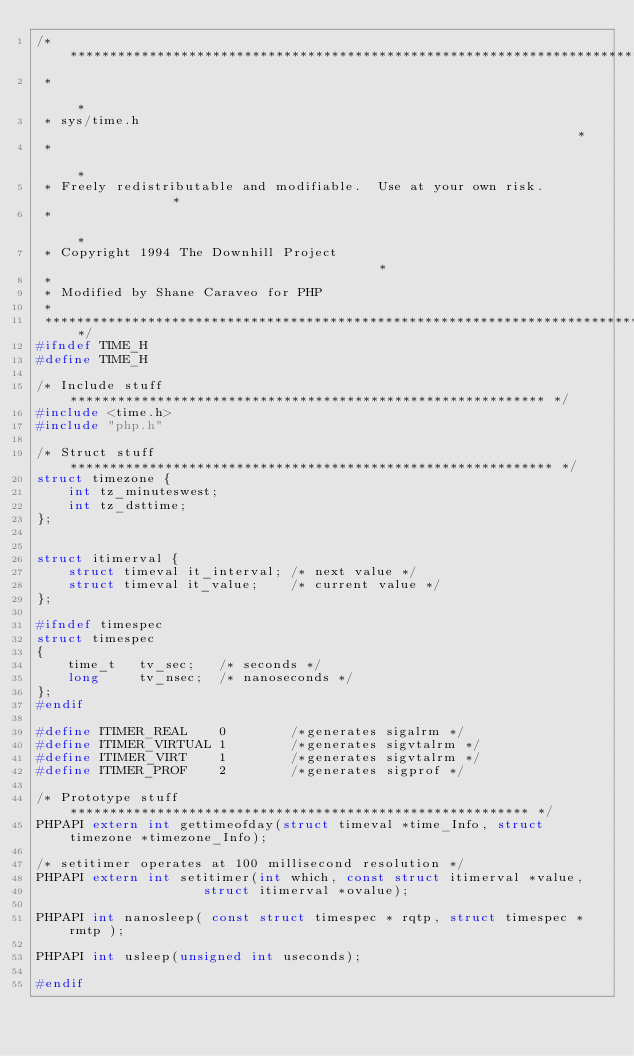<code> <loc_0><loc_0><loc_500><loc_500><_C_>/*****************************************************************************
 *                                                                           *
 * sys/time.h                                                                *
 *                                                                           *
 * Freely redistributable and modifiable.  Use at your own risk.             *
 *                                                                           *
 * Copyright 1994 The Downhill Project                                       *
 *
 * Modified by Shane Caraveo for PHP
 *
 *****************************************************************************/
#ifndef TIME_H
#define TIME_H

/* Include stuff ************************************************************ */
#include <time.h>
#include "php.h"

/* Struct stuff ************************************************************* */
struct timezone {
	int tz_minuteswest;
	int tz_dsttime;
};


struct itimerval {
	struct timeval it_interval;	/* next value */
	struct timeval it_value;	/* current value */
};

#ifndef timespec
struct timespec
{
	time_t   tv_sec;   /* seconds */
	long     tv_nsec;  /* nanoseconds */
};
#endif

#define ITIMER_REAL    0		/*generates sigalrm */
#define ITIMER_VIRTUAL 1		/*generates sigvtalrm */
#define ITIMER_VIRT    1		/*generates sigvtalrm */
#define ITIMER_PROF    2		/*generates sigprof */

/* Prototype stuff ********************************************************** */
PHPAPI extern int gettimeofday(struct timeval *time_Info, struct timezone *timezone_Info);

/* setitimer operates at 100 millisecond resolution */
PHPAPI extern int setitimer(int which, const struct itimerval *value,
					 struct itimerval *ovalue);

PHPAPI int nanosleep( const struct timespec * rqtp, struct timespec * rmtp );

PHPAPI int usleep(unsigned int useconds);

#endif
</code> 